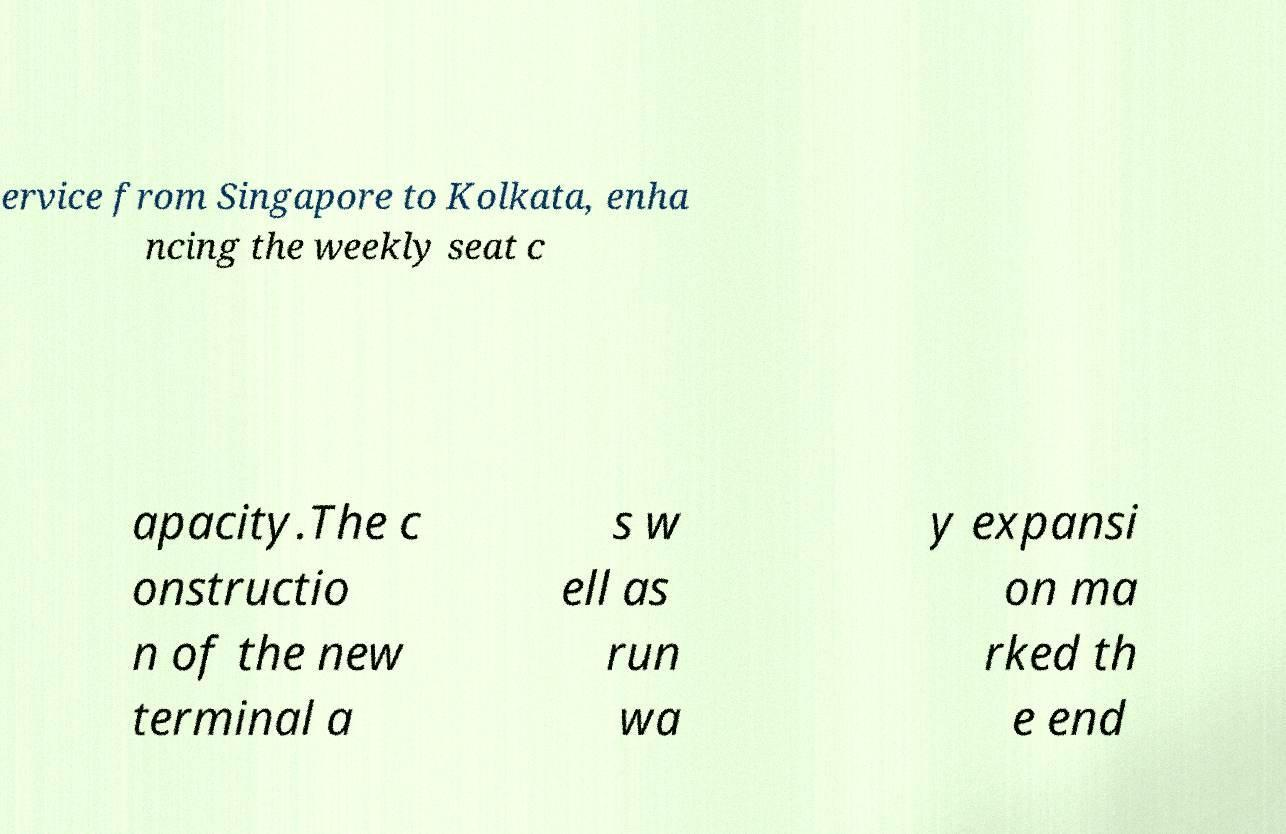Please identify and transcribe the text found in this image. ervice from Singapore to Kolkata, enha ncing the weekly seat c apacity.The c onstructio n of the new terminal a s w ell as run wa y expansi on ma rked th e end 